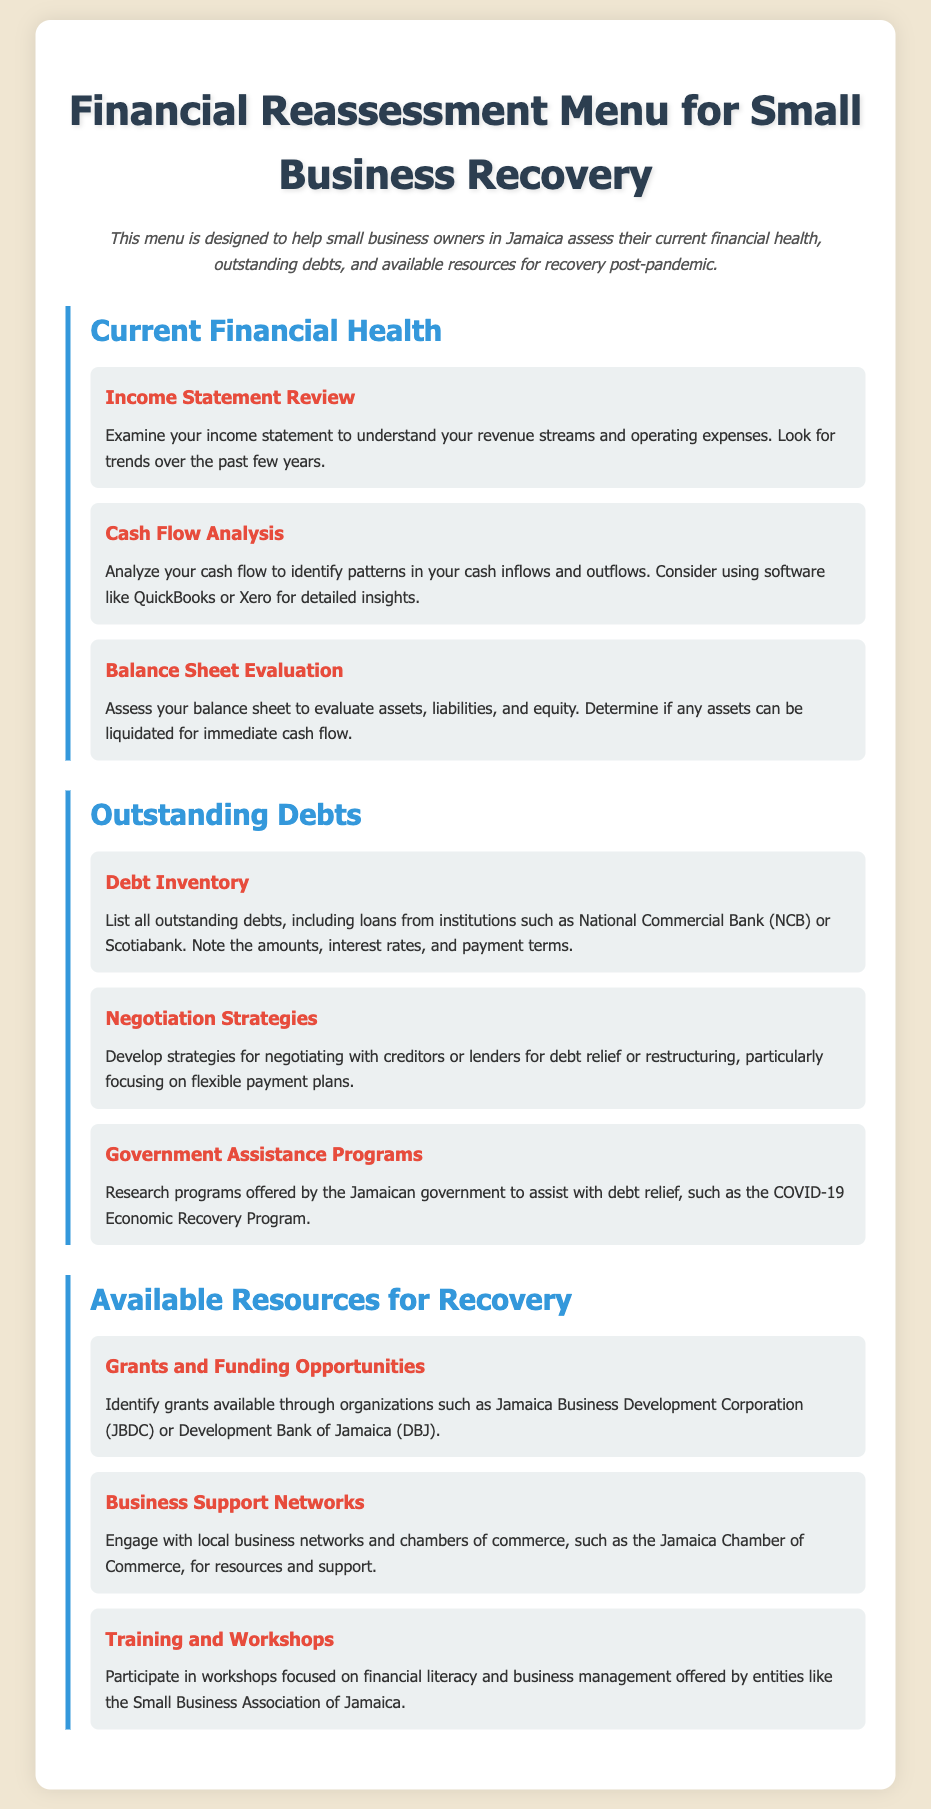What is the title of the document? The title of the document, as stated in the header, is related to financial reassessment for recovery.
Answer: Financial Reassessment Menu for Small Business Recovery What organization provides Grants and Funding Opportunities? The document mentions an organization that provides grants available specifically for small businesses.
Answer: Jamaica Business Development Corporation What program is mentioned for Government Assistance? The document includes a specific program aimed at assisting businesses with debt relief.
Answer: COVID-19 Economic Recovery Program What is the first item in the Outstanding Debts section? The first item listed under Outstanding Debts is about compiling an inventory of debts.
Answer: Debt Inventory Which analysis helps identify cash flows? The document provides a specific type of analysis that focuses on cash inflows and outflows for businesses.
Answer: Cash Flow Analysis What type of networks should businesses engage with for support? The document specifies particular networks that can give support to small businesses.
Answer: Local business networks What is a suggested tool for Cash Flow Analysis? The document suggests a specific type of software to aid in cash flow analysis.
Answer: QuickBooks What is the focus of the second item in Current Financial Health? The document identifies a key aspect of financial health related to business assets.
Answer: Balance Sheet Evaluation How many items are listed under Available Resources for Recovery? The document presents the number of items that fall under the resources available for recovery.
Answer: Three 